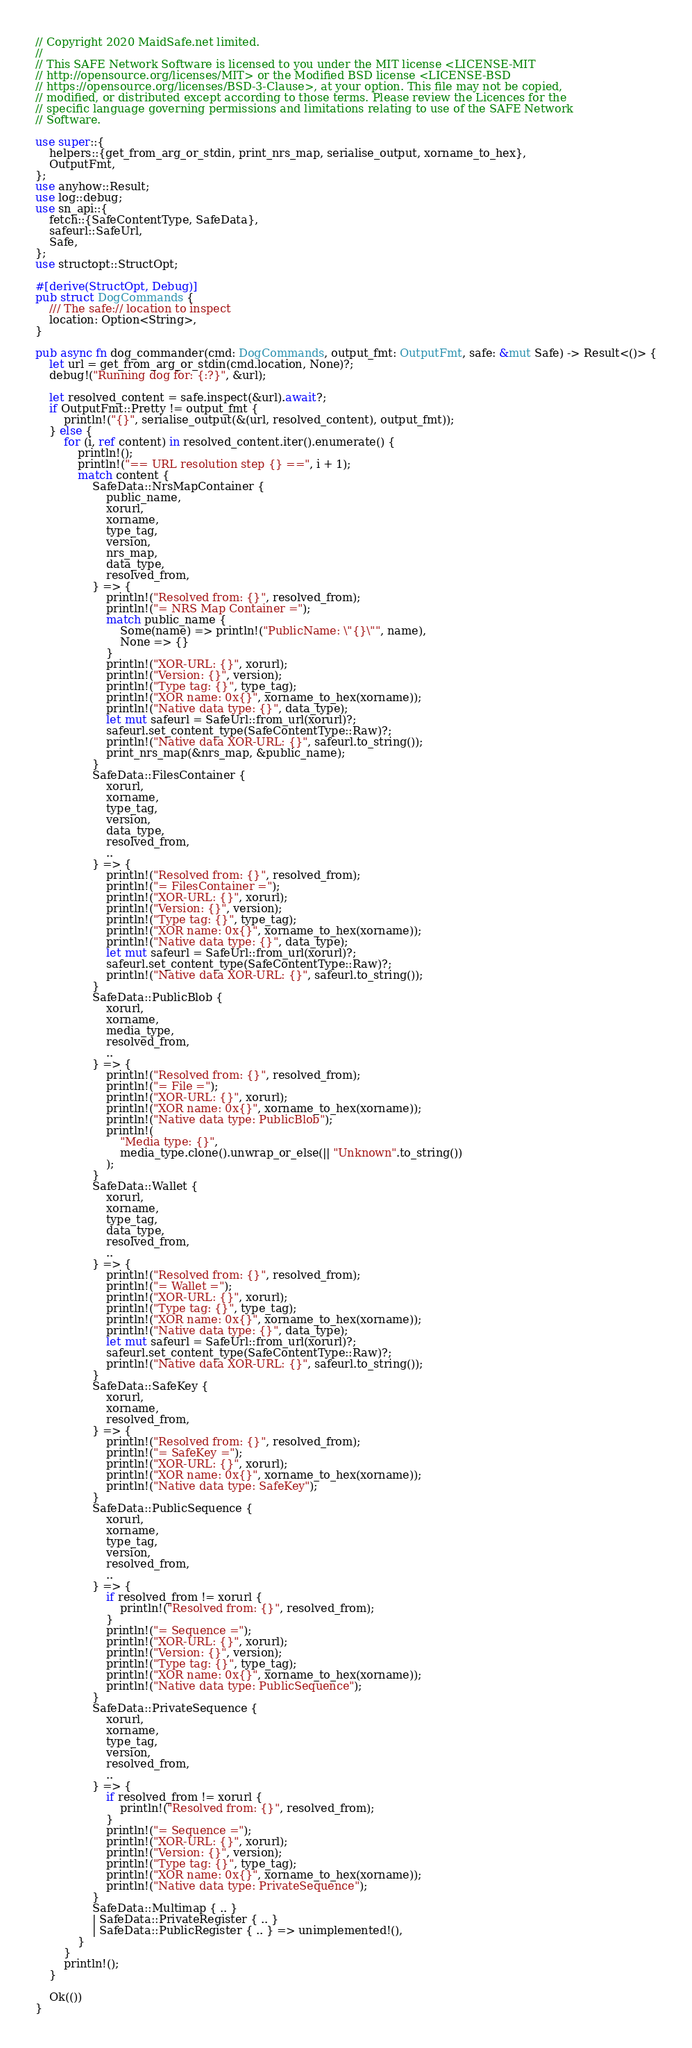<code> <loc_0><loc_0><loc_500><loc_500><_Rust_>// Copyright 2020 MaidSafe.net limited.
//
// This SAFE Network Software is licensed to you under the MIT license <LICENSE-MIT
// http://opensource.org/licenses/MIT> or the Modified BSD license <LICENSE-BSD
// https://opensource.org/licenses/BSD-3-Clause>, at your option. This file may not be copied,
// modified, or distributed except according to those terms. Please review the Licences for the
// specific language governing permissions and limitations relating to use of the SAFE Network
// Software.

use super::{
    helpers::{get_from_arg_or_stdin, print_nrs_map, serialise_output, xorname_to_hex},
    OutputFmt,
};
use anyhow::Result;
use log::debug;
use sn_api::{
    fetch::{SafeContentType, SafeData},
    safeurl::SafeUrl,
    Safe,
};
use structopt::StructOpt;

#[derive(StructOpt, Debug)]
pub struct DogCommands {
    /// The safe:// location to inspect
    location: Option<String>,
}

pub async fn dog_commander(cmd: DogCommands, output_fmt: OutputFmt, safe: &mut Safe) -> Result<()> {
    let url = get_from_arg_or_stdin(cmd.location, None)?;
    debug!("Running dog for: {:?}", &url);

    let resolved_content = safe.inspect(&url).await?;
    if OutputFmt::Pretty != output_fmt {
        println!("{}", serialise_output(&(url, resolved_content), output_fmt));
    } else {
        for (i, ref content) in resolved_content.iter().enumerate() {
            println!();
            println!("== URL resolution step {} ==", i + 1);
            match content {
                SafeData::NrsMapContainer {
                    public_name,
                    xorurl,
                    xorname,
                    type_tag,
                    version,
                    nrs_map,
                    data_type,
                    resolved_from,
                } => {
                    println!("Resolved from: {}", resolved_from);
                    println!("= NRS Map Container =");
                    match public_name {
                        Some(name) => println!("PublicName: \"{}\"", name),
                        None => {}
                    }
                    println!("XOR-URL: {}", xorurl);
                    println!("Version: {}", version);
                    println!("Type tag: {}", type_tag);
                    println!("XOR name: 0x{}", xorname_to_hex(xorname));
                    println!("Native data type: {}", data_type);
                    let mut safeurl = SafeUrl::from_url(xorurl)?;
                    safeurl.set_content_type(SafeContentType::Raw)?;
                    println!("Native data XOR-URL: {}", safeurl.to_string());
                    print_nrs_map(&nrs_map, &public_name);
                }
                SafeData::FilesContainer {
                    xorurl,
                    xorname,
                    type_tag,
                    version,
                    data_type,
                    resolved_from,
                    ..
                } => {
                    println!("Resolved from: {}", resolved_from);
                    println!("= FilesContainer =");
                    println!("XOR-URL: {}", xorurl);
                    println!("Version: {}", version);
                    println!("Type tag: {}", type_tag);
                    println!("XOR name: 0x{}", xorname_to_hex(xorname));
                    println!("Native data type: {}", data_type);
                    let mut safeurl = SafeUrl::from_url(xorurl)?;
                    safeurl.set_content_type(SafeContentType::Raw)?;
                    println!("Native data XOR-URL: {}", safeurl.to_string());
                }
                SafeData::PublicBlob {
                    xorurl,
                    xorname,
                    media_type,
                    resolved_from,
                    ..
                } => {
                    println!("Resolved from: {}", resolved_from);
                    println!("= File =");
                    println!("XOR-URL: {}", xorurl);
                    println!("XOR name: 0x{}", xorname_to_hex(xorname));
                    println!("Native data type: PublicBlob");
                    println!(
                        "Media type: {}",
                        media_type.clone().unwrap_or_else(|| "Unknown".to_string())
                    );
                }
                SafeData::Wallet {
                    xorurl,
                    xorname,
                    type_tag,
                    data_type,
                    resolved_from,
                    ..
                } => {
                    println!("Resolved from: {}", resolved_from);
                    println!("= Wallet =");
                    println!("XOR-URL: {}", xorurl);
                    println!("Type tag: {}", type_tag);
                    println!("XOR name: 0x{}", xorname_to_hex(xorname));
                    println!("Native data type: {}", data_type);
                    let mut safeurl = SafeUrl::from_url(xorurl)?;
                    safeurl.set_content_type(SafeContentType::Raw)?;
                    println!("Native data XOR-URL: {}", safeurl.to_string());
                }
                SafeData::SafeKey {
                    xorurl,
                    xorname,
                    resolved_from,
                } => {
                    println!("Resolved from: {}", resolved_from);
                    println!("= SafeKey =");
                    println!("XOR-URL: {}", xorurl);
                    println!("XOR name: 0x{}", xorname_to_hex(xorname));
                    println!("Native data type: SafeKey");
                }
                SafeData::PublicSequence {
                    xorurl,
                    xorname,
                    type_tag,
                    version,
                    resolved_from,
                    ..
                } => {
                    if resolved_from != xorurl {
                        println!("Resolved from: {}", resolved_from);
                    }
                    println!("= Sequence =");
                    println!("XOR-URL: {}", xorurl);
                    println!("Version: {}", version);
                    println!("Type tag: {}", type_tag);
                    println!("XOR name: 0x{}", xorname_to_hex(xorname));
                    println!("Native data type: PublicSequence");
                }
                SafeData::PrivateSequence {
                    xorurl,
                    xorname,
                    type_tag,
                    version,
                    resolved_from,
                    ..
                } => {
                    if resolved_from != xorurl {
                        println!("Resolved from: {}", resolved_from);
                    }
                    println!("= Sequence =");
                    println!("XOR-URL: {}", xorurl);
                    println!("Version: {}", version);
                    println!("Type tag: {}", type_tag);
                    println!("XOR name: 0x{}", xorname_to_hex(xorname));
                    println!("Native data type: PrivateSequence");
                }
                SafeData::Multimap { .. }
                | SafeData::PrivateRegister { .. }
                | SafeData::PublicRegister { .. } => unimplemented!(),
            }
        }
        println!();
    }

    Ok(())
}
</code> 